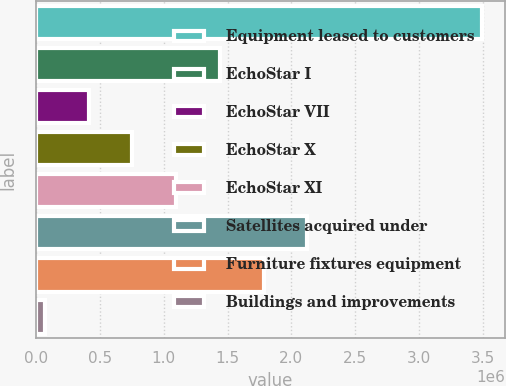Convert chart to OTSL. <chart><loc_0><loc_0><loc_500><loc_500><bar_chart><fcel>Equipment leased to customers<fcel>EchoStar I<fcel>EchoStar VII<fcel>EchoStar X<fcel>EchoStar XI<fcel>Satellites acquired under<fcel>Furniture fixtures equipment<fcel>Buildings and improvements<nl><fcel>3.49536e+06<fcel>1.44043e+06<fcel>412960<fcel>755449<fcel>1.09794e+06<fcel>2.1254e+06<fcel>1.78292e+06<fcel>70471<nl></chart> 